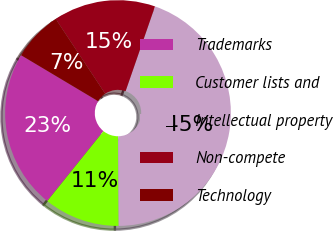Convert chart to OTSL. <chart><loc_0><loc_0><loc_500><loc_500><pie_chart><fcel>Trademarks<fcel>Customer lists and<fcel>Intellectual property<fcel>Non-compete<fcel>Technology<nl><fcel>22.79%<fcel>10.87%<fcel>44.59%<fcel>14.62%<fcel>7.13%<nl></chart> 